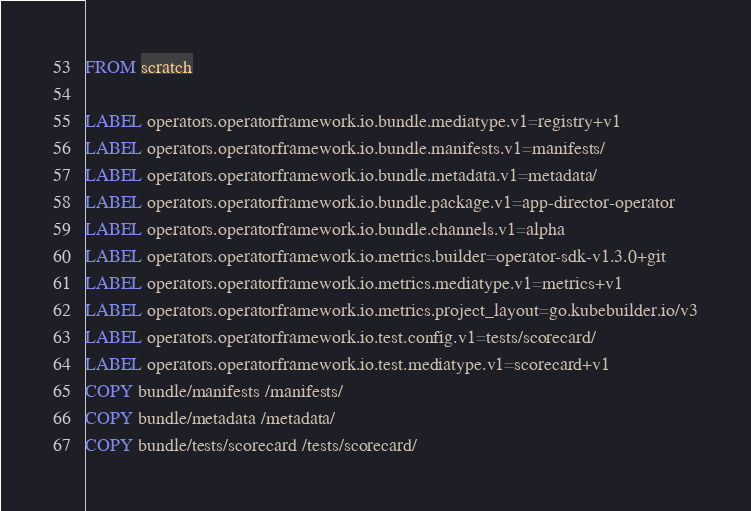Convert code to text. <code><loc_0><loc_0><loc_500><loc_500><_Dockerfile_>FROM scratch

LABEL operators.operatorframework.io.bundle.mediatype.v1=registry+v1
LABEL operators.operatorframework.io.bundle.manifests.v1=manifests/
LABEL operators.operatorframework.io.bundle.metadata.v1=metadata/
LABEL operators.operatorframework.io.bundle.package.v1=app-director-operator
LABEL operators.operatorframework.io.bundle.channels.v1=alpha
LABEL operators.operatorframework.io.metrics.builder=operator-sdk-v1.3.0+git
LABEL operators.operatorframework.io.metrics.mediatype.v1=metrics+v1
LABEL operators.operatorframework.io.metrics.project_layout=go.kubebuilder.io/v3
LABEL operators.operatorframework.io.test.config.v1=tests/scorecard/
LABEL operators.operatorframework.io.test.mediatype.v1=scorecard+v1
COPY bundle/manifests /manifests/
COPY bundle/metadata /metadata/
COPY bundle/tests/scorecard /tests/scorecard/
</code> 